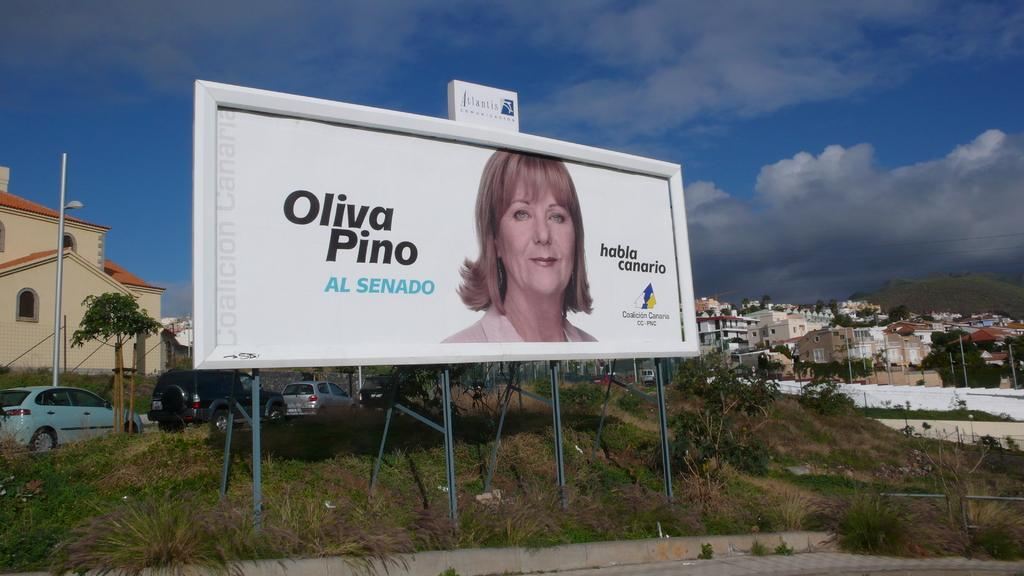<image>
Present a compact description of the photo's key features. A billboard of a woman with the words Oliva Pino printed on the side in front of a suburb. 